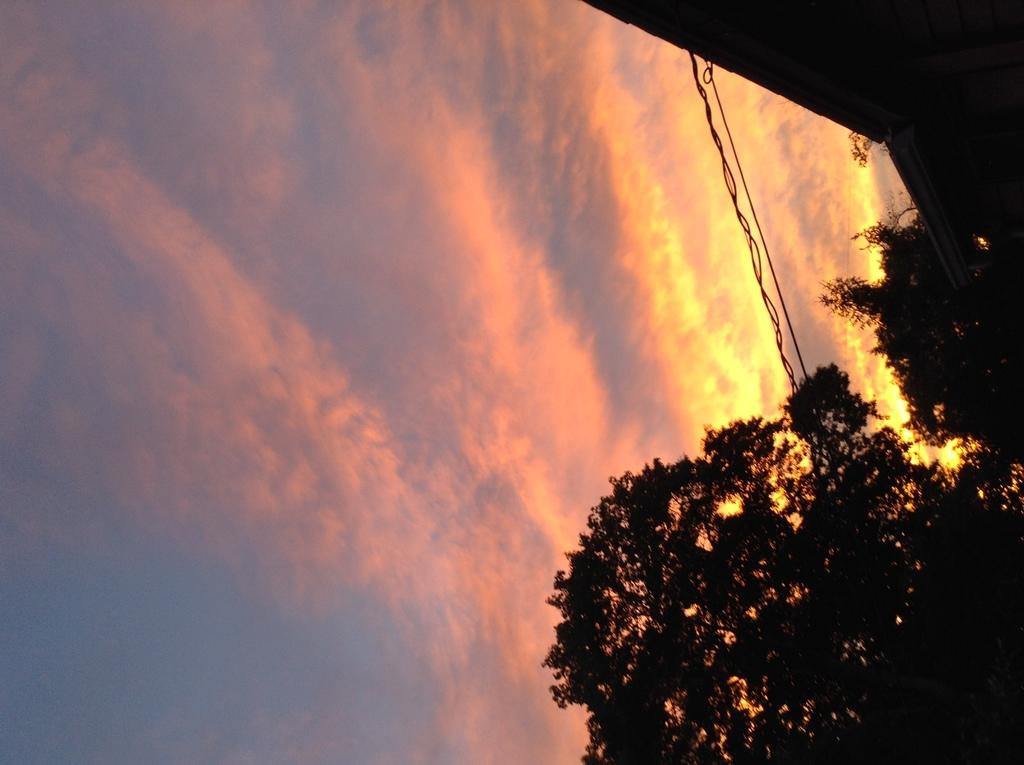What type of natural element is present in the image? There is a tree in the image. What man-made object can be seen in the image? There is a wire from a building in the image. What is visible in the background of the image? The background of the image includes a sky. What can be observed in the sky in the image? Clouds are visible in the sky. What type of prose is being recited by the tree in the image? There is no indication in the image that the tree is reciting any prose. What organization is responsible for the wire from the building in the image? The image does not provide enough information to determine which organization is responsible for the wire from the building. 